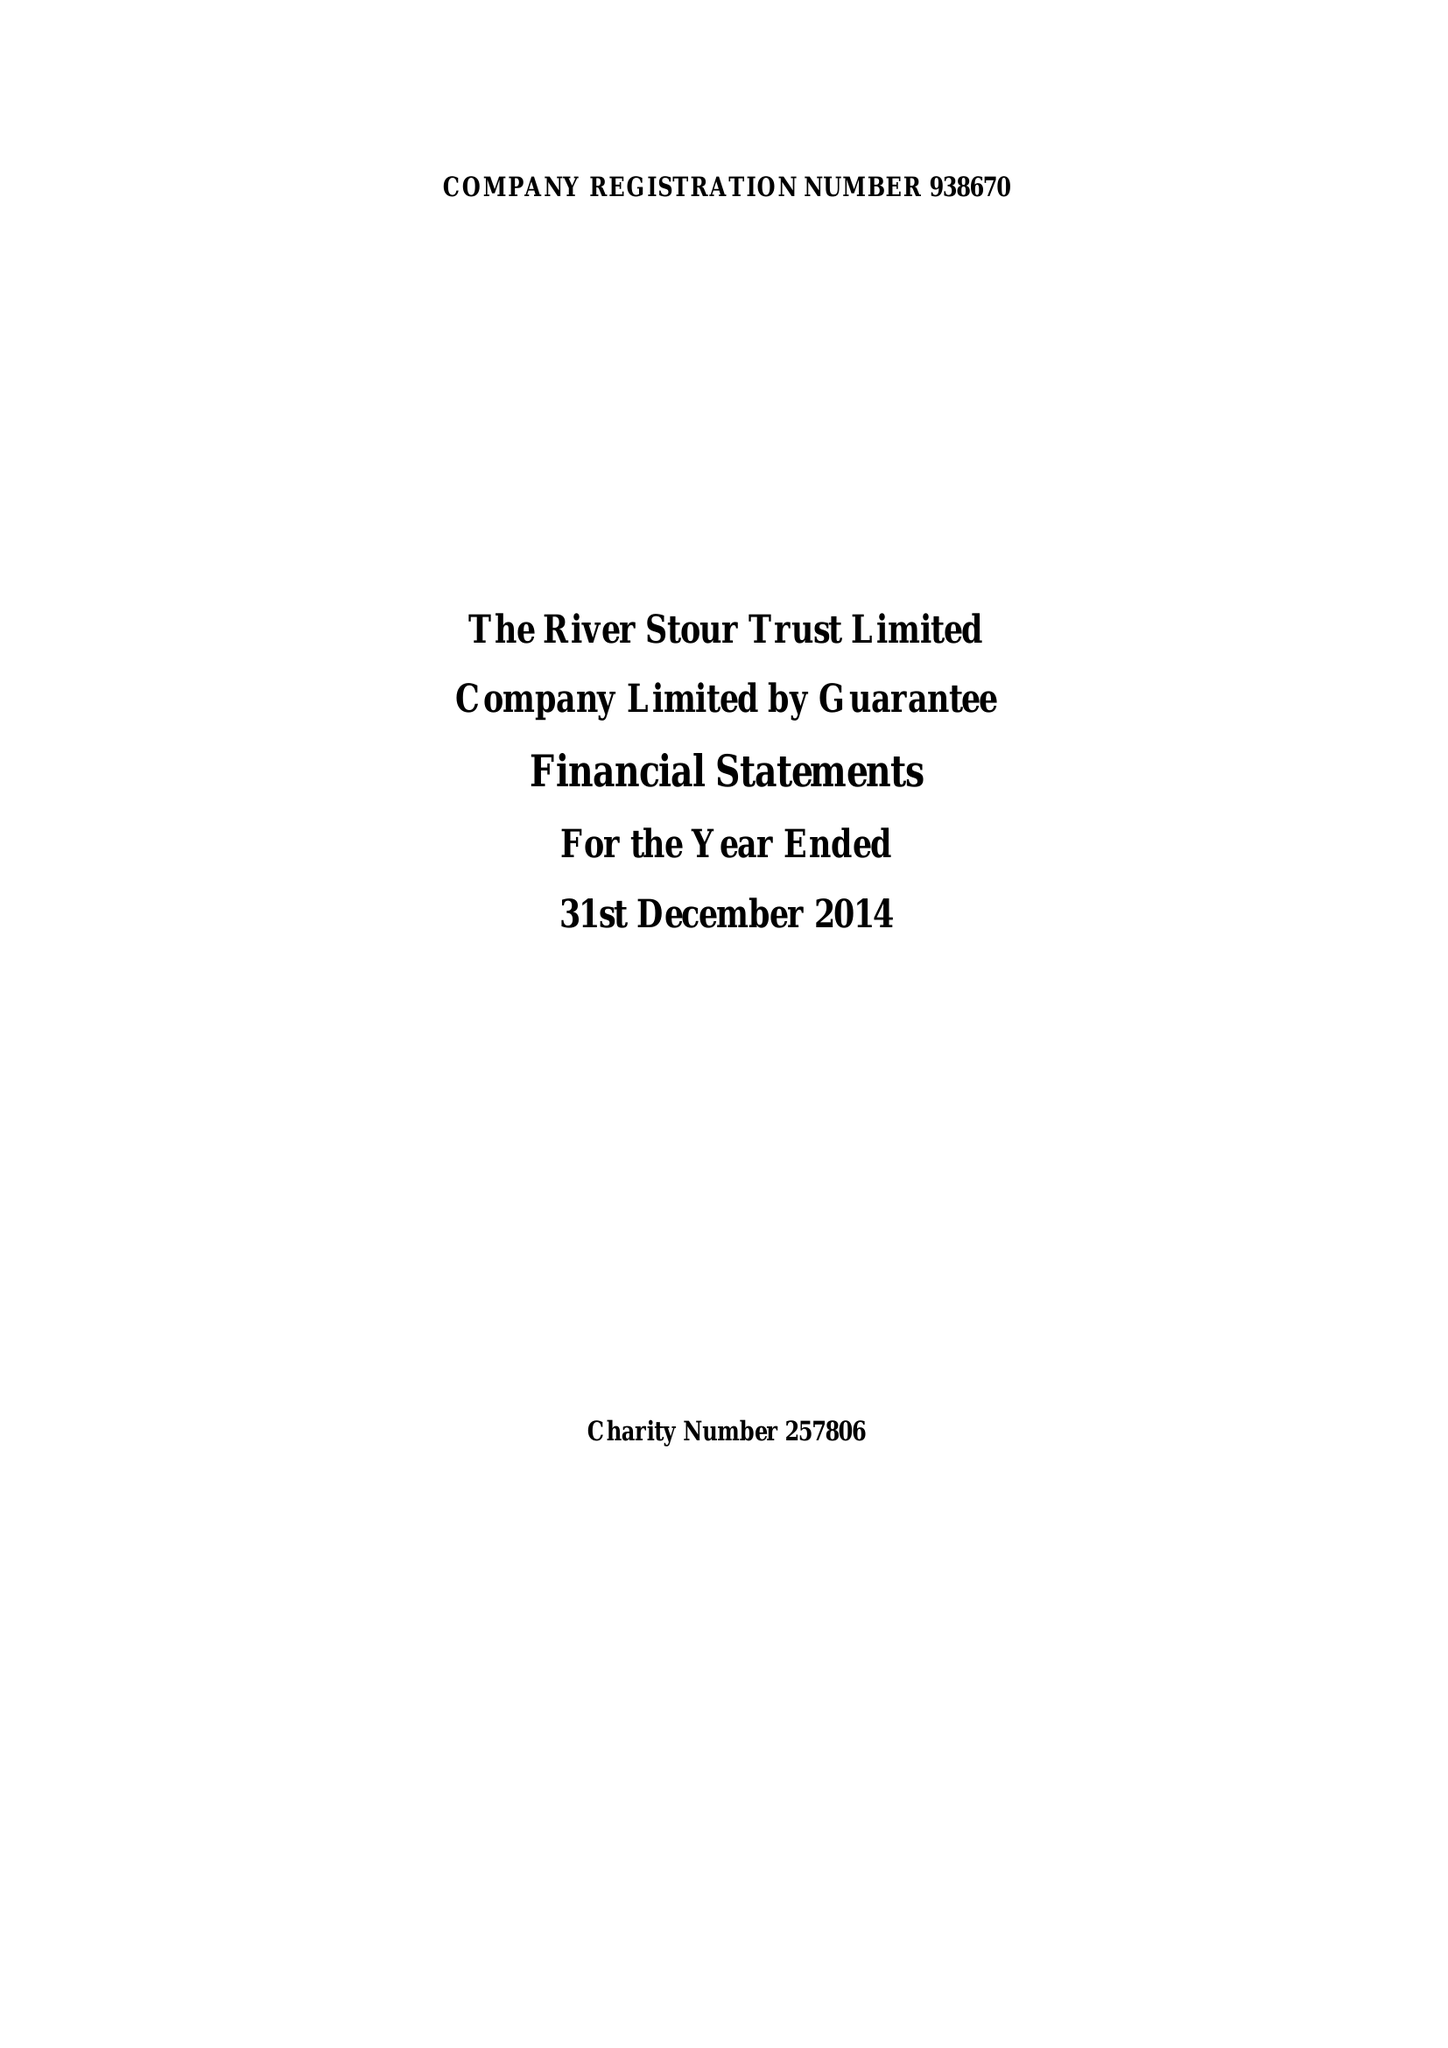What is the value for the report_date?
Answer the question using a single word or phrase. 2014-12-31 